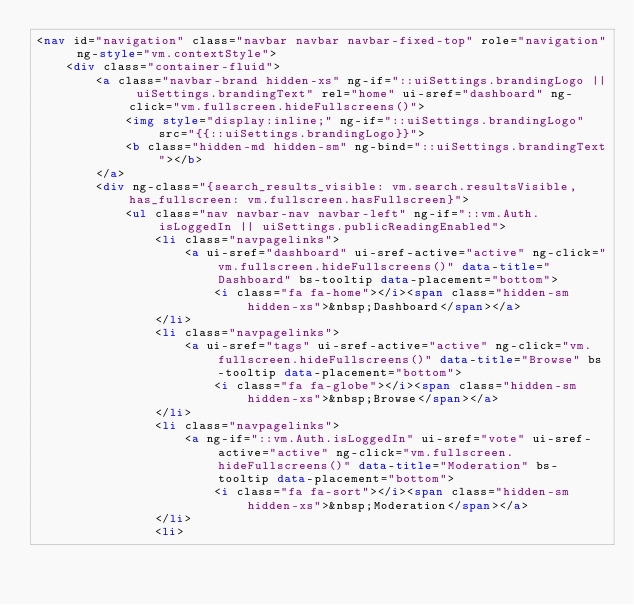Convert code to text. <code><loc_0><loc_0><loc_500><loc_500><_HTML_><nav id="navigation" class="navbar navbar navbar-fixed-top" role="navigation" ng-style="vm.contextStyle">
    <div class="container-fluid">
        <a class="navbar-brand hidden-xs" ng-if="::uiSettings.brandingLogo || uiSettings.brandingText" rel="home" ui-sref="dashboard" ng-click="vm.fullscreen.hideFullscreens()">
            <img style="display:inline;" ng-if="::uiSettings.brandingLogo" src="{{::uiSettings.brandingLogo}}">
            <b class="hidden-md hidden-sm" ng-bind="::uiSettings.brandingText"></b>
        </a>
        <div ng-class="{search_results_visible: vm.search.resultsVisible, has_fullscreen: vm.fullscreen.hasFullscreen}">
            <ul class="nav navbar-nav navbar-left" ng-if="::vm.Auth.isLoggedIn || uiSettings.publicReadingEnabled">
                <li class="navpagelinks">
                    <a ui-sref="dashboard" ui-sref-active="active" ng-click="vm.fullscreen.hideFullscreens()" data-title="Dashboard" bs-tooltip data-placement="bottom">
                        <i class="fa fa-home"></i><span class="hidden-sm hidden-xs">&nbsp;Dashboard</span></a>
                </li>
                <li class="navpagelinks">
                    <a ui-sref="tags" ui-sref-active="active" ng-click="vm.fullscreen.hideFullscreens()" data-title="Browse" bs-tooltip data-placement="bottom">
                        <i class="fa fa-globe"></i><span class="hidden-sm hidden-xs">&nbsp;Browse</span></a>
                </li>
                <li class="navpagelinks">
                    <a ng-if="::vm.Auth.isLoggedIn" ui-sref="vote" ui-sref-active="active" ng-click="vm.fullscreen.hideFullscreens()" data-title="Moderation" bs-tooltip data-placement="bottom">
                        <i class="fa fa-sort"></i><span class="hidden-sm hidden-xs">&nbsp;Moderation</span></a>
                </li>
                <li></code> 